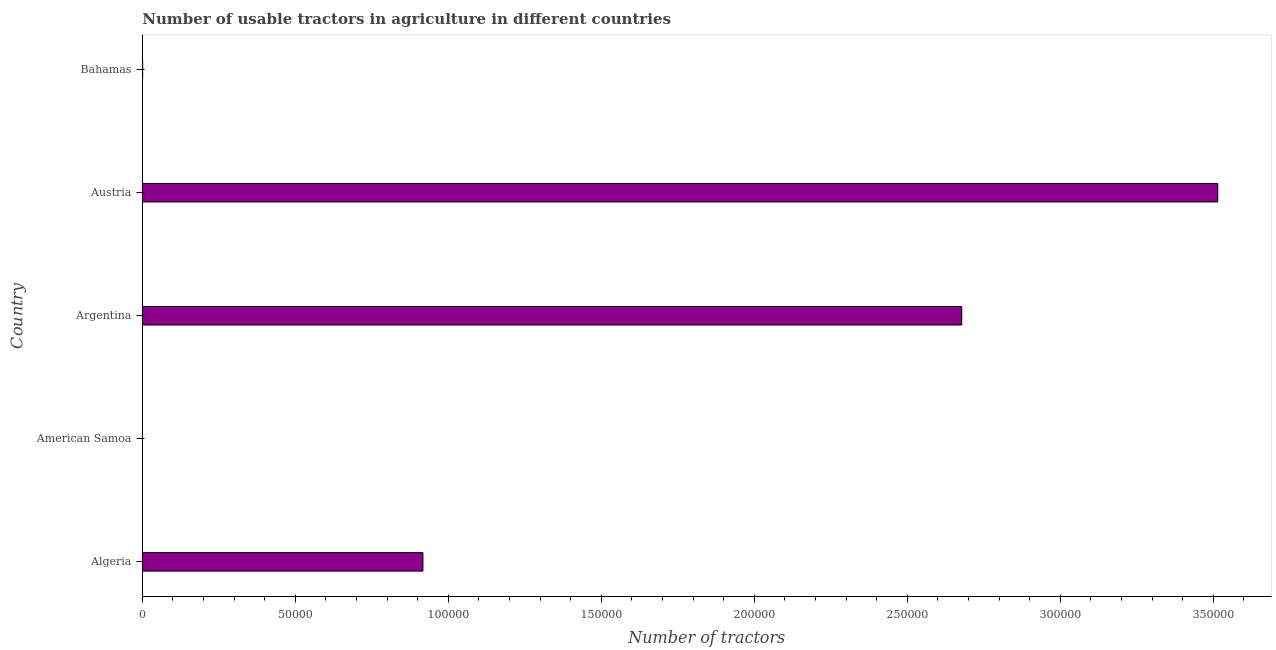What is the title of the graph?
Provide a short and direct response. Number of usable tractors in agriculture in different countries. What is the label or title of the X-axis?
Provide a succinct answer. Number of tractors. What is the label or title of the Y-axis?
Provide a short and direct response. Country. What is the number of tractors in Austria?
Your response must be concise. 3.51e+05. Across all countries, what is the maximum number of tractors?
Offer a very short reply. 3.51e+05. Across all countries, what is the minimum number of tractors?
Provide a succinct answer. 11. In which country was the number of tractors minimum?
Your answer should be compact. American Samoa. What is the sum of the number of tractors?
Offer a very short reply. 7.11e+05. What is the difference between the number of tractors in American Samoa and Austria?
Your answer should be very brief. -3.51e+05. What is the average number of tractors per country?
Your answer should be compact. 1.42e+05. What is the median number of tractors?
Your answer should be very brief. 9.17e+04. In how many countries, is the number of tractors greater than 290000 ?
Offer a very short reply. 1. What is the ratio of the number of tractors in Algeria to that in Argentina?
Keep it short and to the point. 0.34. Is the difference between the number of tractors in Austria and Bahamas greater than the difference between any two countries?
Offer a very short reply. No. What is the difference between the highest and the second highest number of tractors?
Give a very brief answer. 8.37e+04. Is the sum of the number of tractors in Algeria and Bahamas greater than the maximum number of tractors across all countries?
Your answer should be compact. No. What is the difference between the highest and the lowest number of tractors?
Give a very brief answer. 3.51e+05. How many bars are there?
Offer a very short reply. 5. How many countries are there in the graph?
Your answer should be compact. 5. What is the Number of tractors in Algeria?
Offer a very short reply. 9.17e+04. What is the Number of tractors of Argentina?
Offer a very short reply. 2.68e+05. What is the Number of tractors in Austria?
Your answer should be very brief. 3.51e+05. What is the Number of tractors in Bahamas?
Offer a very short reply. 107. What is the difference between the Number of tractors in Algeria and American Samoa?
Provide a short and direct response. 9.17e+04. What is the difference between the Number of tractors in Algeria and Argentina?
Ensure brevity in your answer.  -1.76e+05. What is the difference between the Number of tractors in Algeria and Austria?
Your answer should be very brief. -2.60e+05. What is the difference between the Number of tractors in Algeria and Bahamas?
Provide a short and direct response. 9.16e+04. What is the difference between the Number of tractors in American Samoa and Argentina?
Give a very brief answer. -2.68e+05. What is the difference between the Number of tractors in American Samoa and Austria?
Keep it short and to the point. -3.51e+05. What is the difference between the Number of tractors in American Samoa and Bahamas?
Give a very brief answer. -96. What is the difference between the Number of tractors in Argentina and Austria?
Your answer should be very brief. -8.37e+04. What is the difference between the Number of tractors in Argentina and Bahamas?
Your answer should be very brief. 2.68e+05. What is the difference between the Number of tractors in Austria and Bahamas?
Offer a terse response. 3.51e+05. What is the ratio of the Number of tractors in Algeria to that in American Samoa?
Offer a terse response. 8336.36. What is the ratio of the Number of tractors in Algeria to that in Argentina?
Keep it short and to the point. 0.34. What is the ratio of the Number of tractors in Algeria to that in Austria?
Keep it short and to the point. 0.26. What is the ratio of the Number of tractors in Algeria to that in Bahamas?
Keep it short and to the point. 857.01. What is the ratio of the Number of tractors in American Samoa to that in Austria?
Offer a terse response. 0. What is the ratio of the Number of tractors in American Samoa to that in Bahamas?
Your answer should be very brief. 0.1. What is the ratio of the Number of tractors in Argentina to that in Austria?
Your response must be concise. 0.76. What is the ratio of the Number of tractors in Argentina to that in Bahamas?
Give a very brief answer. 2502.64. What is the ratio of the Number of tractors in Austria to that in Bahamas?
Offer a terse response. 3284.52. 